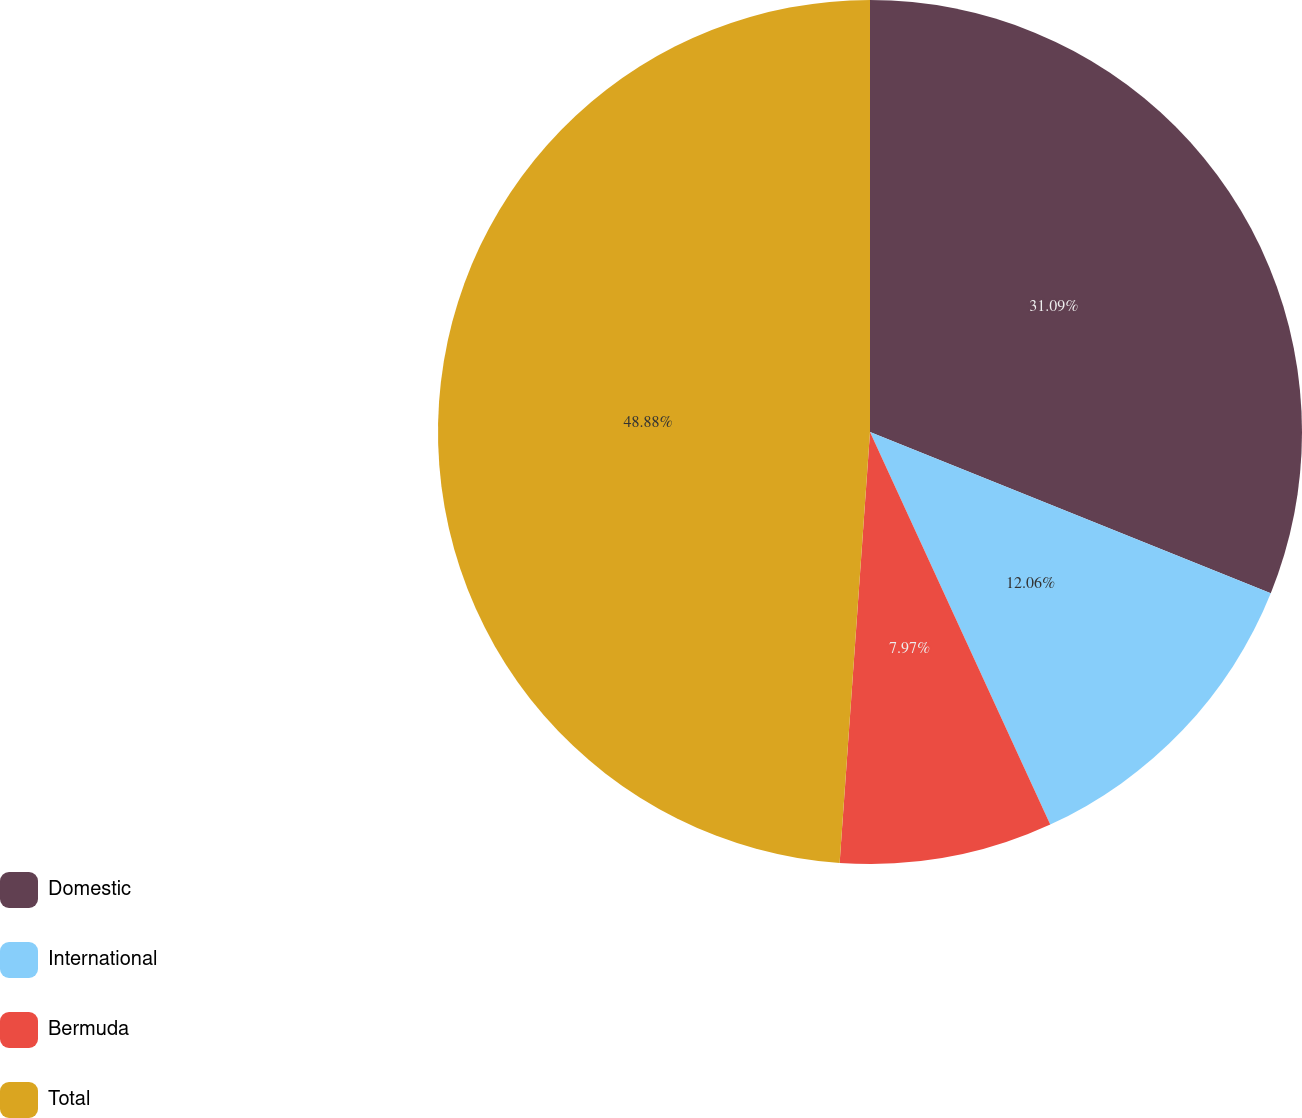Convert chart to OTSL. <chart><loc_0><loc_0><loc_500><loc_500><pie_chart><fcel>Domestic<fcel>International<fcel>Bermuda<fcel>Total<nl><fcel>31.09%<fcel>12.06%<fcel>7.97%<fcel>48.88%<nl></chart> 